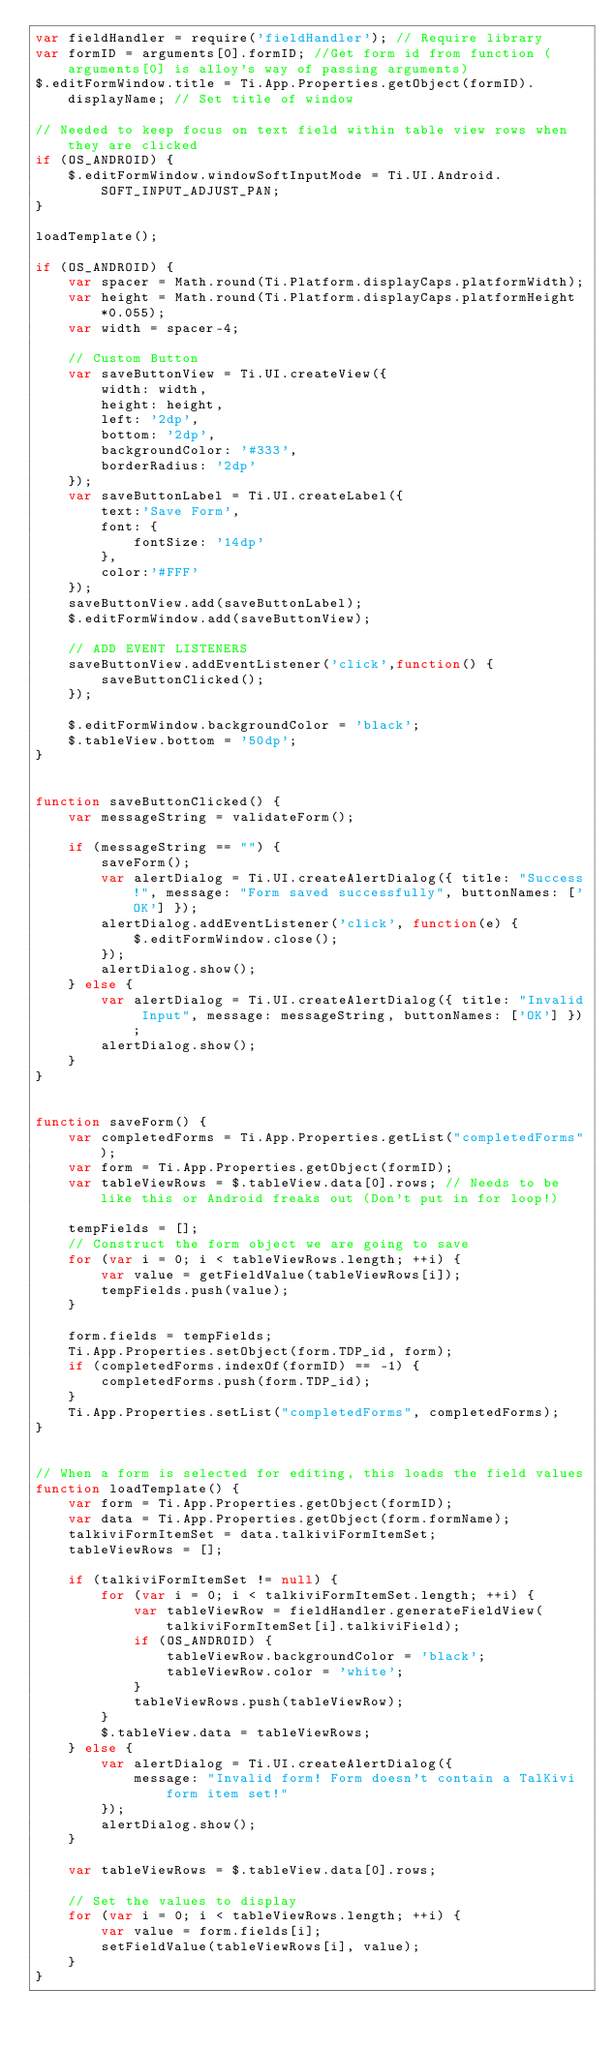<code> <loc_0><loc_0><loc_500><loc_500><_JavaScript_>var fieldHandler = require('fieldHandler'); // Require library
var formID = arguments[0].formID; //Get form id from function (arguments[0] is alloy's way of passing arguments)
$.editFormWindow.title = Ti.App.Properties.getObject(formID).displayName; // Set title of window

// Needed to keep focus on text field within table view rows when they are clicked
if (OS_ANDROID) {
	$.editFormWindow.windowSoftInputMode = Ti.UI.Android.SOFT_INPUT_ADJUST_PAN;
}

loadTemplate();

if (OS_ANDROID) {
	var spacer = Math.round(Ti.Platform.displayCaps.platformWidth);
	var height = Math.round(Ti.Platform.displayCaps.platformHeight*0.055);
	var width = spacer-4;

	// Custom Button
	var saveButtonView = Ti.UI.createView({
	    width: width,
	    height: height,
	    left: '2dp',
	    bottom: '2dp',
	    backgroundColor: '#333',
	    borderRadius: '2dp'
	});
	var saveButtonLabel = Ti.UI.createLabel({
	    text:'Save Form',
	    font: {
	    	fontSize: '14dp'
	    },
	    color:'#FFF'
	});
	saveButtonView.add(saveButtonLabel);
	$.editFormWindow.add(saveButtonView);
	
	// ADD EVENT LISTENERS
	saveButtonView.addEventListener('click',function() {
		saveButtonClicked();
	});
	
	$.editFormWindow.backgroundColor = 'black';
	$.tableView.bottom = '50dp';
}


function saveButtonClicked() {
	var messageString = validateForm();
	
	if (messageString == "") {
		saveForm();
		var alertDialog = Ti.UI.createAlertDialog({ title: "Success!", message: "Form saved successfully", buttonNames: ['OK'] });
		alertDialog.addEventListener('click', function(e) {
			$.editFormWindow.close();
		});
		alertDialog.show();
	} else {
		var alertDialog = Ti.UI.createAlertDialog({ title: "Invalid Input", message: messageString, buttonNames: ['OK'] });
		alertDialog.show();
	}
}


function saveForm() {
	var completedForms = Ti.App.Properties.getList("completedForms");
	var form = Ti.App.Properties.getObject(formID);
	var tableViewRows = $.tableView.data[0].rows; // Needs to be like this or Android freaks out (Don't put in for loop!)
	
	tempFields = [];
	// Construct the form object we are going to save
	for (var i = 0; i < tableViewRows.length; ++i) {
		var value = getFieldValue(tableViewRows[i]);
		tempFields.push(value);
	}
	
	form.fields = tempFields;
	Ti.App.Properties.setObject(form.TDP_id, form);
	if (completedForms.indexOf(formID) == -1) {
		completedForms.push(form.TDP_id);
	}
	Ti.App.Properties.setList("completedForms", completedForms);
}


// When a form is selected for editing, this loads the field values
function loadTemplate() {
	var form = Ti.App.Properties.getObject(formID);
	var data = Ti.App.Properties.getObject(form.formName);
	talkiviFormItemSet = data.talkiviFormItemSet;
	tableViewRows = [];
	
	if (talkiviFormItemSet != null) {
		for (var i = 0; i < talkiviFormItemSet.length; ++i) {
			var tableViewRow = fieldHandler.generateFieldView(talkiviFormItemSet[i].talkiviField);
			if (OS_ANDROID) {
				tableViewRow.backgroundColor = 'black';
				tableViewRow.color = 'white';
			}
			tableViewRows.push(tableViewRow);
		}
		$.tableView.data = tableViewRows;
	} else {
		var alertDialog = Ti.UI.createAlertDialog({
			message: "Invalid form! Form doesn't contain a TalKivi form item set!"
		});
		alertDialog.show();
	}
	
	var tableViewRows = $.tableView.data[0].rows;
	
	// Set the values to display
	for (var i = 0; i < tableViewRows.length; ++i) {
		var value = form.fields[i];
		setFieldValue(tableViewRows[i], value);
	}
}

</code> 